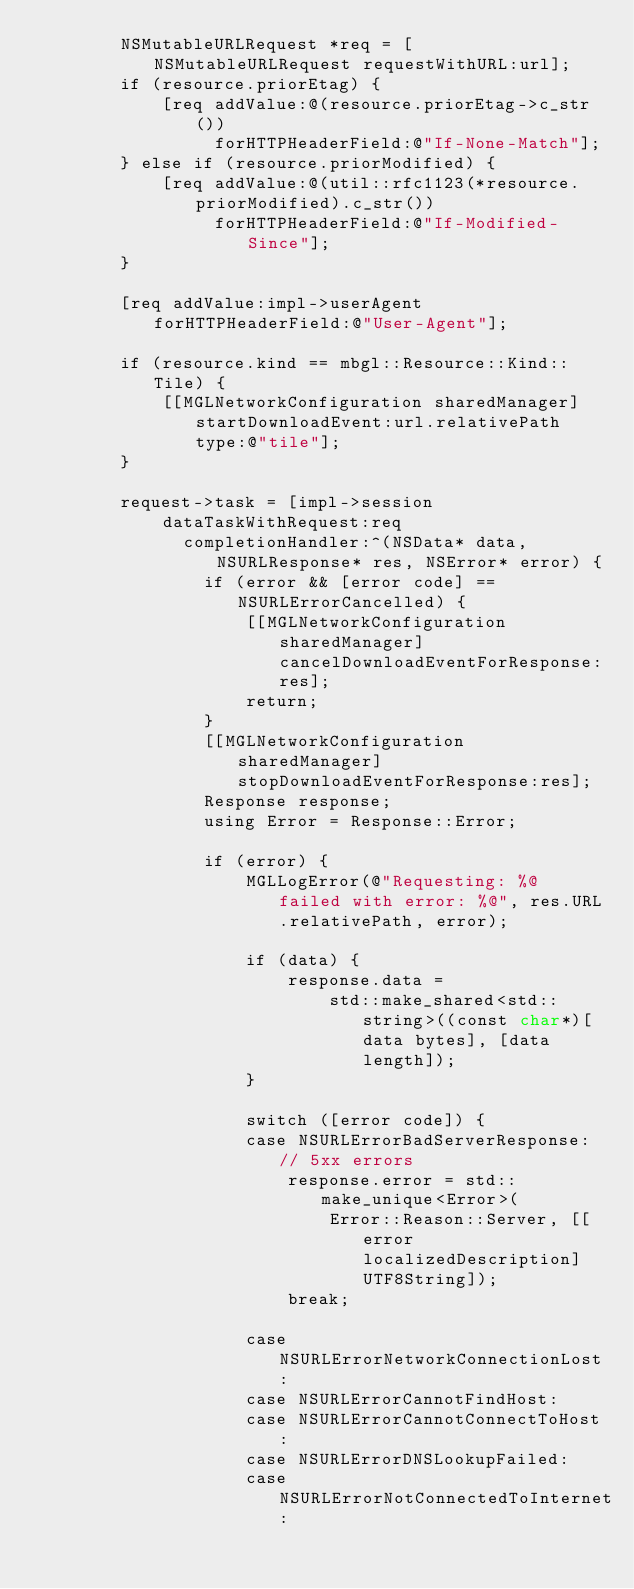<code> <loc_0><loc_0><loc_500><loc_500><_ObjectiveC_>        NSMutableURLRequest *req = [NSMutableURLRequest requestWithURL:url];
        if (resource.priorEtag) {
            [req addValue:@(resource.priorEtag->c_str())
                 forHTTPHeaderField:@"If-None-Match"];
        } else if (resource.priorModified) {
            [req addValue:@(util::rfc1123(*resource.priorModified).c_str())
                 forHTTPHeaderField:@"If-Modified-Since"];
        }

        [req addValue:impl->userAgent forHTTPHeaderField:@"User-Agent"];
        
        if (resource.kind == mbgl::Resource::Kind::Tile) {
            [[MGLNetworkConfiguration sharedManager] startDownloadEvent:url.relativePath type:@"tile"];
        }
        
        request->task = [impl->session
            dataTaskWithRequest:req
              completionHandler:^(NSData* data, NSURLResponse* res, NSError* error) {
                if (error && [error code] == NSURLErrorCancelled) {
                    [[MGLNetworkConfiguration sharedManager] cancelDownloadEventForResponse:res];
                    return;
                }
                [[MGLNetworkConfiguration sharedManager] stopDownloadEventForResponse:res];
                Response response;
                using Error = Response::Error;

                if (error) {
                    MGLLogError(@"Requesting: %@ failed with error: %@", res.URL.relativePath, error);
                    
                    if (data) {
                        response.data =
                            std::make_shared<std::string>((const char*)[data bytes], [data length]);
                    }

                    switch ([error code]) {
                    case NSURLErrorBadServerResponse: // 5xx errors
                        response.error = std::make_unique<Error>(
                            Error::Reason::Server, [[error localizedDescription] UTF8String]);
                        break;

                    case NSURLErrorNetworkConnectionLost:
                    case NSURLErrorCannotFindHost:
                    case NSURLErrorCannotConnectToHost:
                    case NSURLErrorDNSLookupFailed:
                    case NSURLErrorNotConnectedToInternet:</code> 